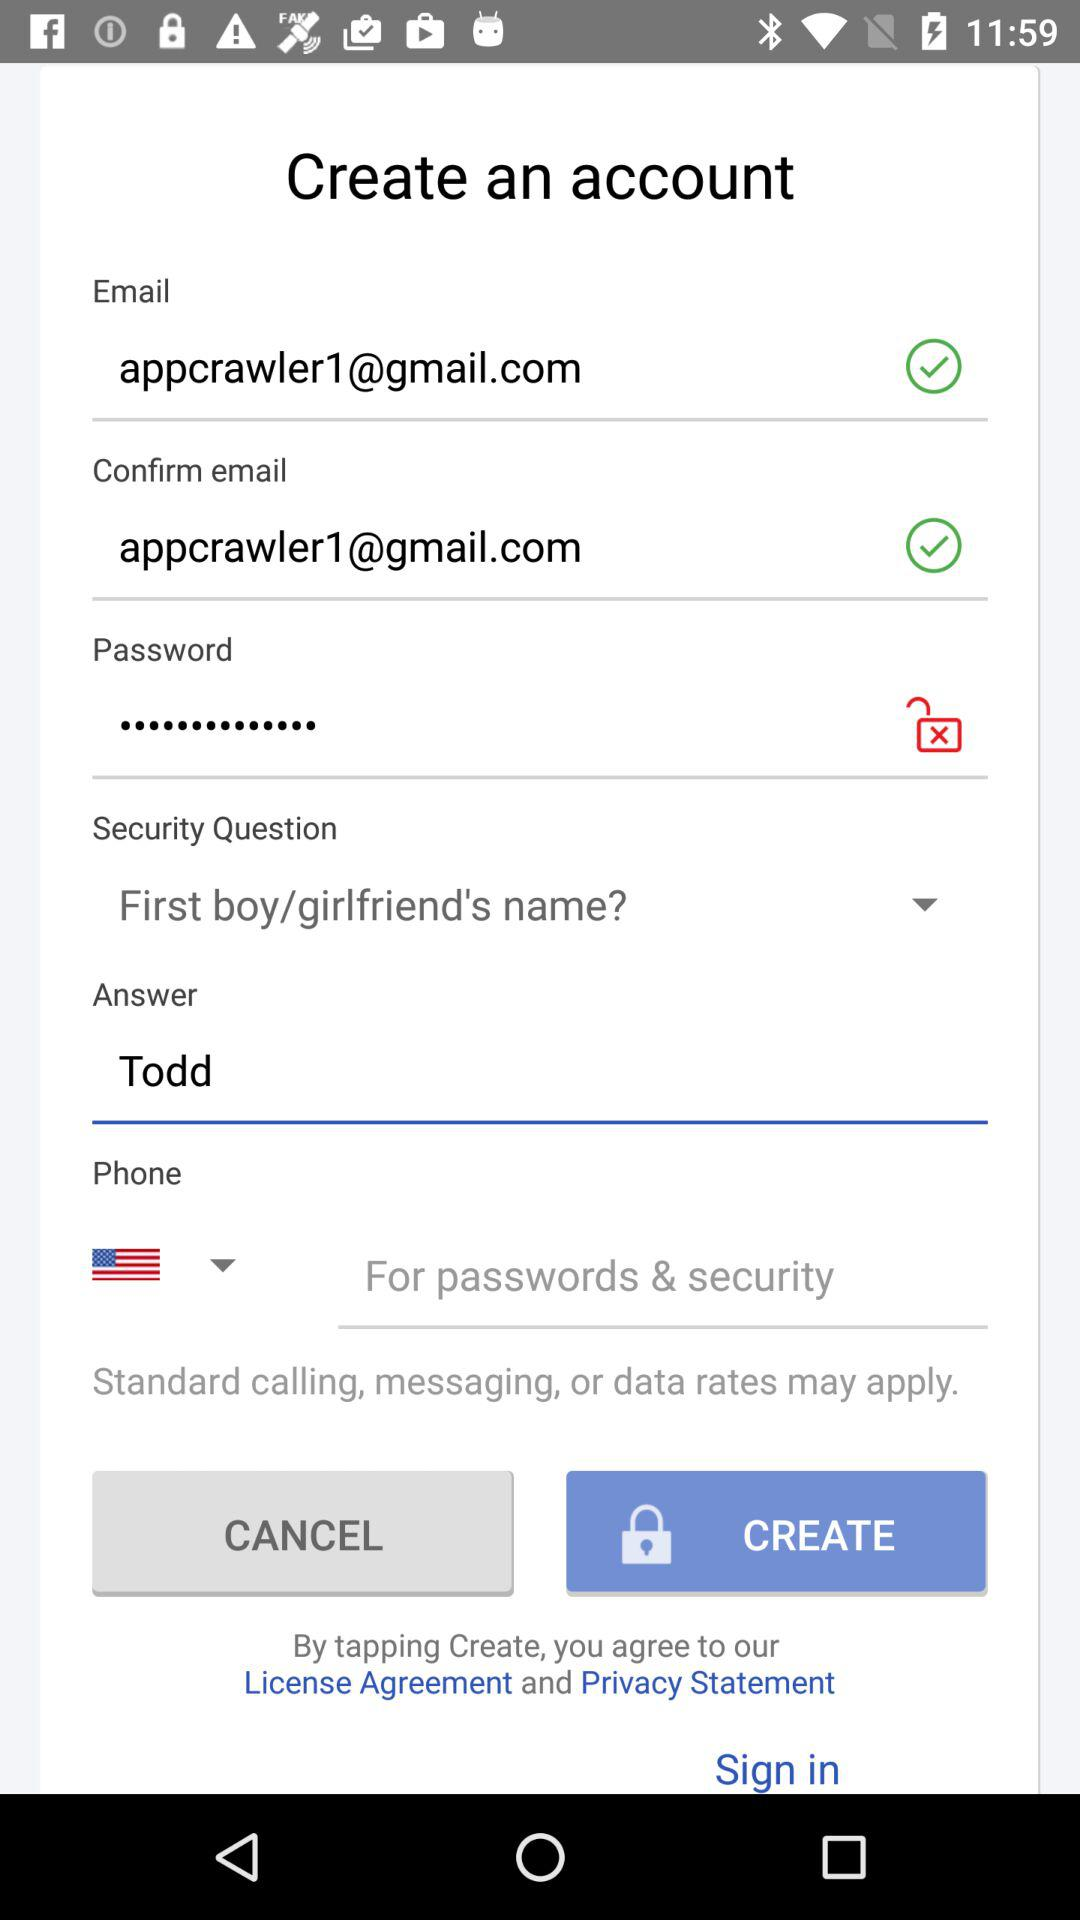What is the entered phone number?
When the provided information is insufficient, respond with <no answer>. <no answer> 